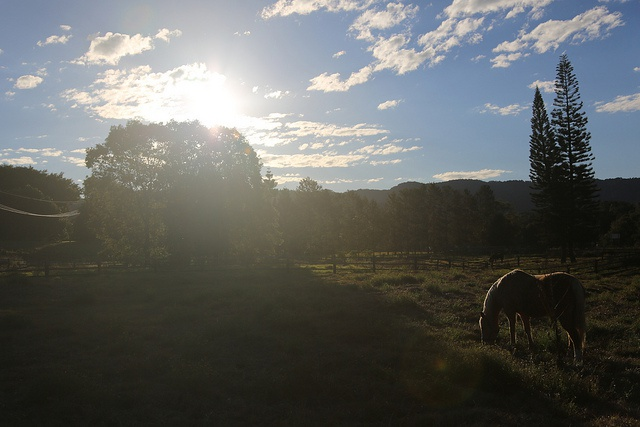Describe the objects in this image and their specific colors. I can see a horse in gray, black, and tan tones in this image. 